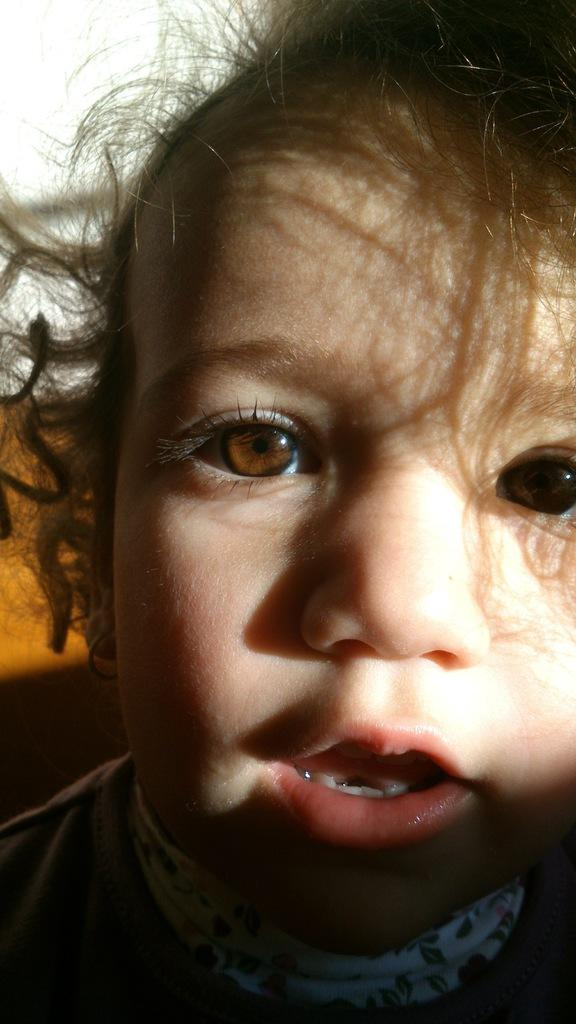What is the main subject of the image? There is a boy in the image. What is the boy wearing? The boy is wearing a T-shirt. Can you describe the background of the image? The background of the image appears blurry. What type of mine can be seen in the background of the image? There is no mine present in the image; the background appears blurry. 